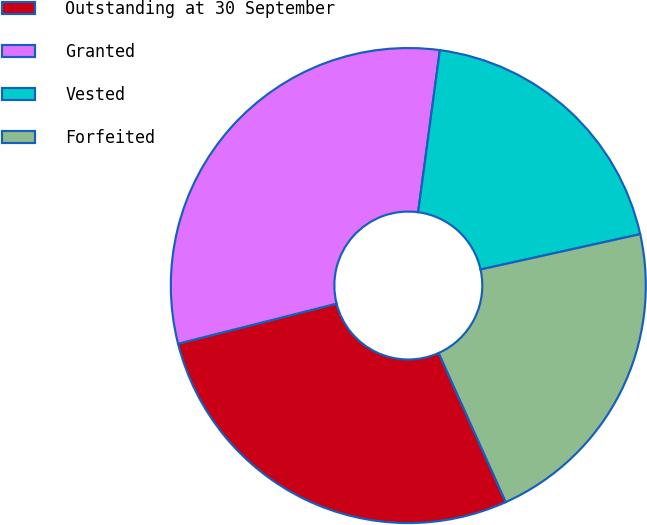Convert chart. <chart><loc_0><loc_0><loc_500><loc_500><pie_chart><fcel>Outstanding at 30 September<fcel>Granted<fcel>Vested<fcel>Forfeited<nl><fcel>27.79%<fcel>31.06%<fcel>19.41%<fcel>21.74%<nl></chart> 